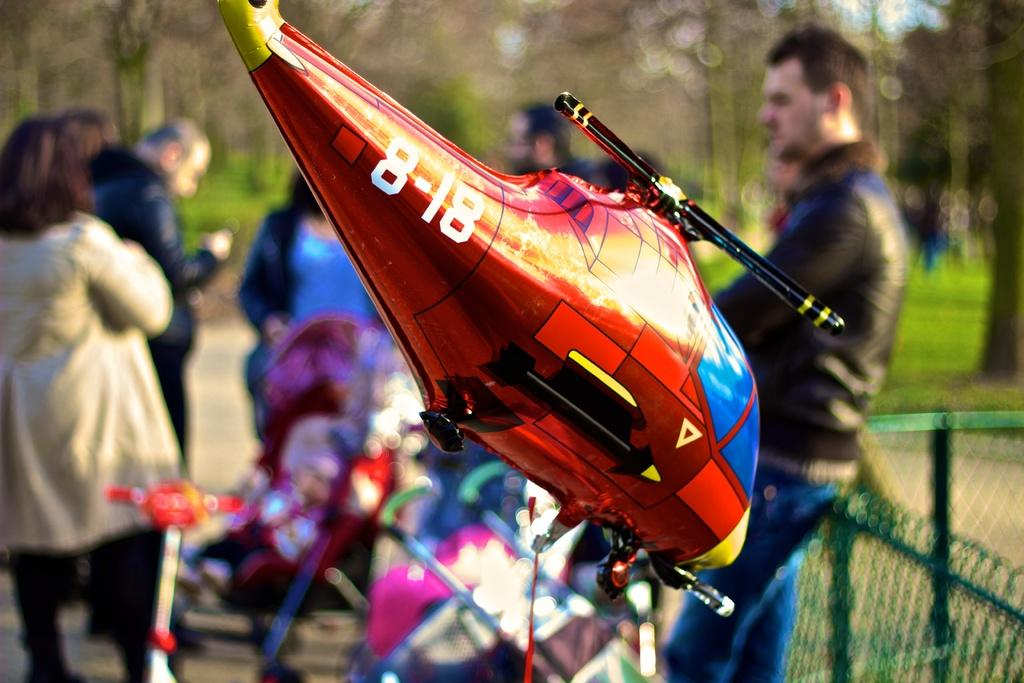<image>
Create a compact narrative representing the image presented. A big red balloon of a helicopter with 8-18 printed on its tail. 